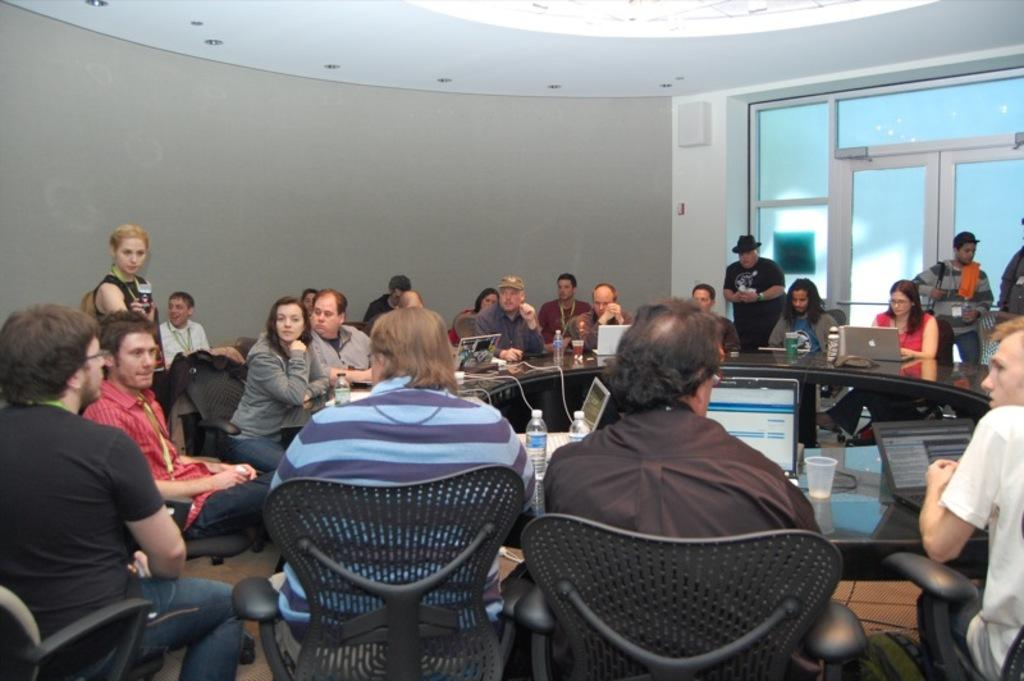What are the people in the image doing? The people in the image are sitting in chairs and some are standing. What objects can be seen on the table in the image? There are laptops and water bottles on the table in the image. Can you describe the door in the image? There is a glass door in the image. What type of fold can be seen in the image? There is no fold present in the image. What kind of apparatus is being used by the people in the image? The people in the image are using laptops, but there is no other apparatus mentioned in the facts. 